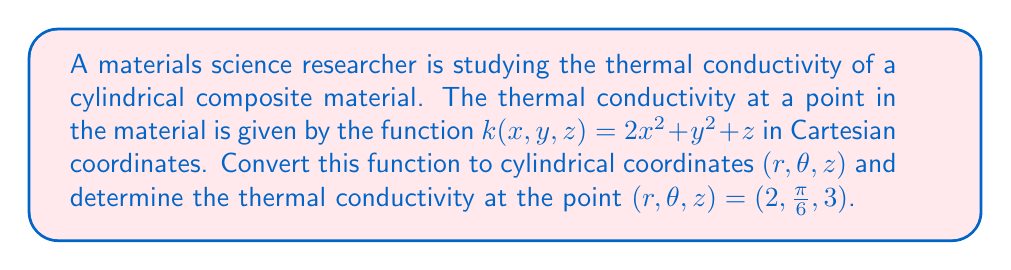Give your solution to this math problem. To solve this problem, we need to follow these steps:

1) First, recall the relationships between Cartesian $(x,y,z)$ and cylindrical $(r,\theta,z)$ coordinates:

   $x = r \cos(\theta)$
   $y = r \sin(\theta)$
   $z = z$

2) Now, we need to substitute these expressions into the original function:

   $k(x,y,z) = 2x^2 + y^2 + z$

   becomes

   $k(r,\theta,z) = 2(r \cos(\theta))^2 + (r \sin(\theta))^2 + z$

3) Simplify this expression:

   $k(r,\theta,z) = 2r^2 \cos^2(\theta) + r^2 \sin^2(\theta) + z$

   $k(r,\theta,z) = r^2(2\cos^2(\theta) + \sin^2(\theta)) + z$

4) We can further simplify using the trigonometric identity $\cos^2(\theta) + \sin^2(\theta) = 1$:

   $k(r,\theta,z) = r^2(\cos^2(\theta) + 1) + z$

5) Now that we have the function in cylindrical coordinates, we can evaluate it at the given point $(r,\theta,z) = (2, \frac{\pi}{6}, 3)$:

   $k(2, \frac{\pi}{6}, 3) = 2^2(\cos^2(\frac{\pi}{6}) + 1) + 3$

6) Evaluate $\cos^2(\frac{\pi}{6})$:

   $\cos(\frac{\pi}{6}) = \frac{\sqrt{3}}{2}$
   
   $\cos^2(\frac{\pi}{6}) = (\frac{\sqrt{3}}{2})^2 = \frac{3}{4}$

7) Substitute this value and calculate:

   $k(2, \frac{\pi}{6}, 3) = 4(\frac{3}{4} + 1) + 3$
                           $= 4(\frac{7}{4}) + 3$
                           $= 7 + 3$
                           $= 10$

Therefore, the thermal conductivity at the point $(r,\theta,z) = (2, \frac{\pi}{6}, 3)$ is 10 units.
Answer: $k(2, \frac{\pi}{6}, 3) = 10$ units 